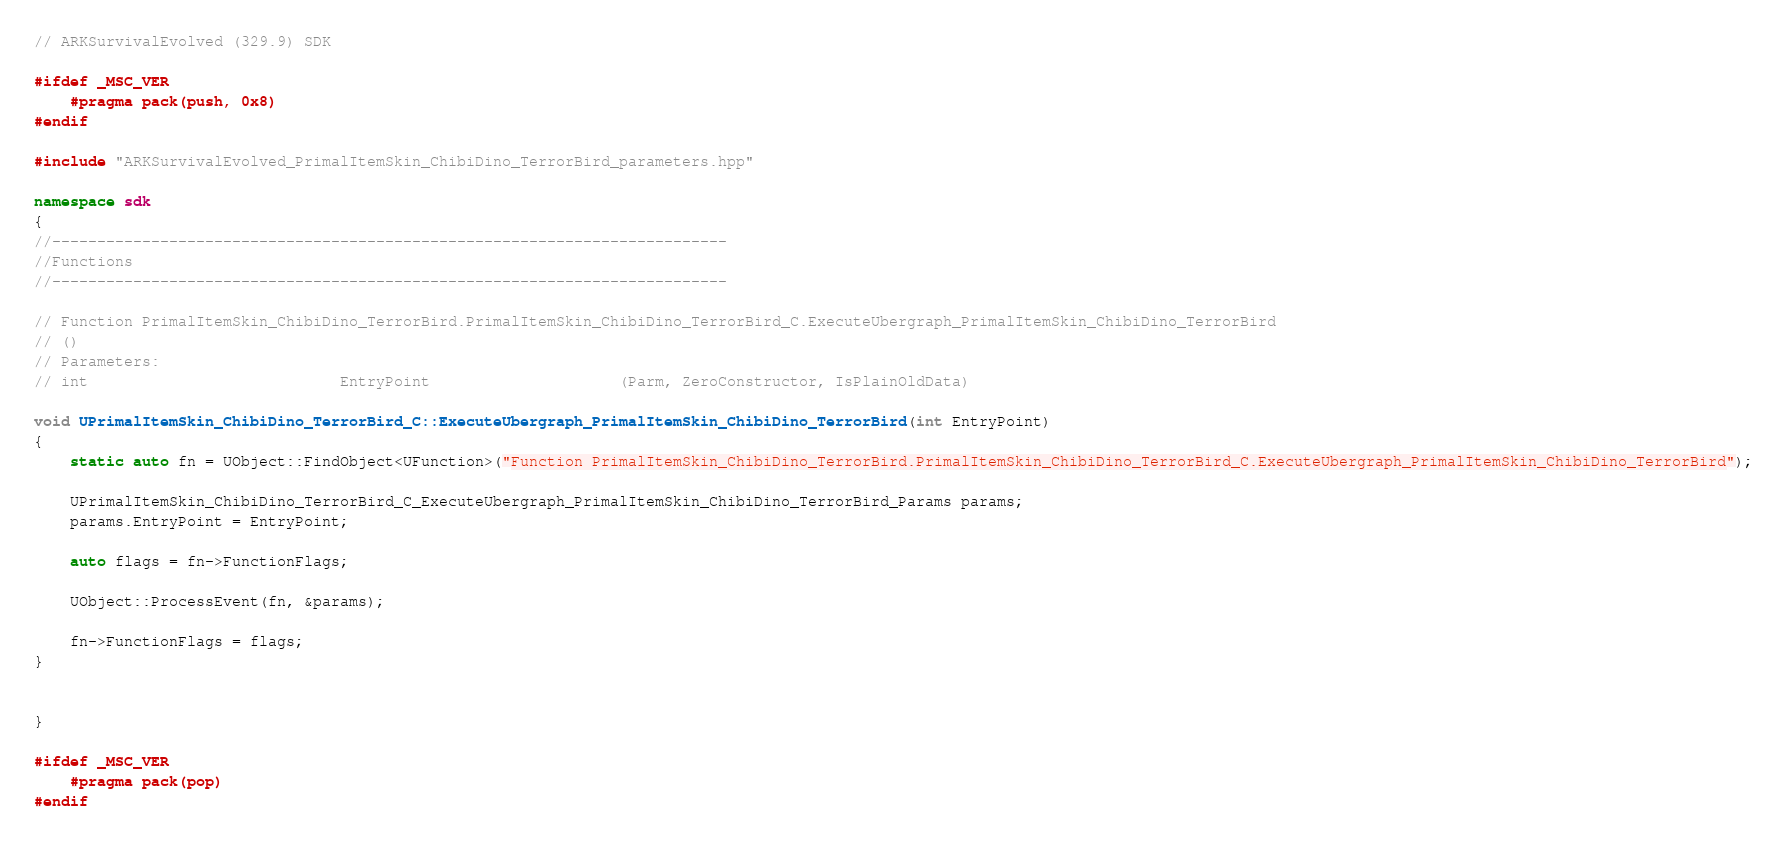<code> <loc_0><loc_0><loc_500><loc_500><_C++_>// ARKSurvivalEvolved (329.9) SDK

#ifdef _MSC_VER
	#pragma pack(push, 0x8)
#endif

#include "ARKSurvivalEvolved_PrimalItemSkin_ChibiDino_TerrorBird_parameters.hpp"

namespace sdk
{
//---------------------------------------------------------------------------
//Functions
//---------------------------------------------------------------------------

// Function PrimalItemSkin_ChibiDino_TerrorBird.PrimalItemSkin_ChibiDino_TerrorBird_C.ExecuteUbergraph_PrimalItemSkin_ChibiDino_TerrorBird
// ()
// Parameters:
// int                            EntryPoint                     (Parm, ZeroConstructor, IsPlainOldData)

void UPrimalItemSkin_ChibiDino_TerrorBird_C::ExecuteUbergraph_PrimalItemSkin_ChibiDino_TerrorBird(int EntryPoint)
{
	static auto fn = UObject::FindObject<UFunction>("Function PrimalItemSkin_ChibiDino_TerrorBird.PrimalItemSkin_ChibiDino_TerrorBird_C.ExecuteUbergraph_PrimalItemSkin_ChibiDino_TerrorBird");

	UPrimalItemSkin_ChibiDino_TerrorBird_C_ExecuteUbergraph_PrimalItemSkin_ChibiDino_TerrorBird_Params params;
	params.EntryPoint = EntryPoint;

	auto flags = fn->FunctionFlags;

	UObject::ProcessEvent(fn, &params);

	fn->FunctionFlags = flags;
}


}

#ifdef _MSC_VER
	#pragma pack(pop)
#endif
</code> 